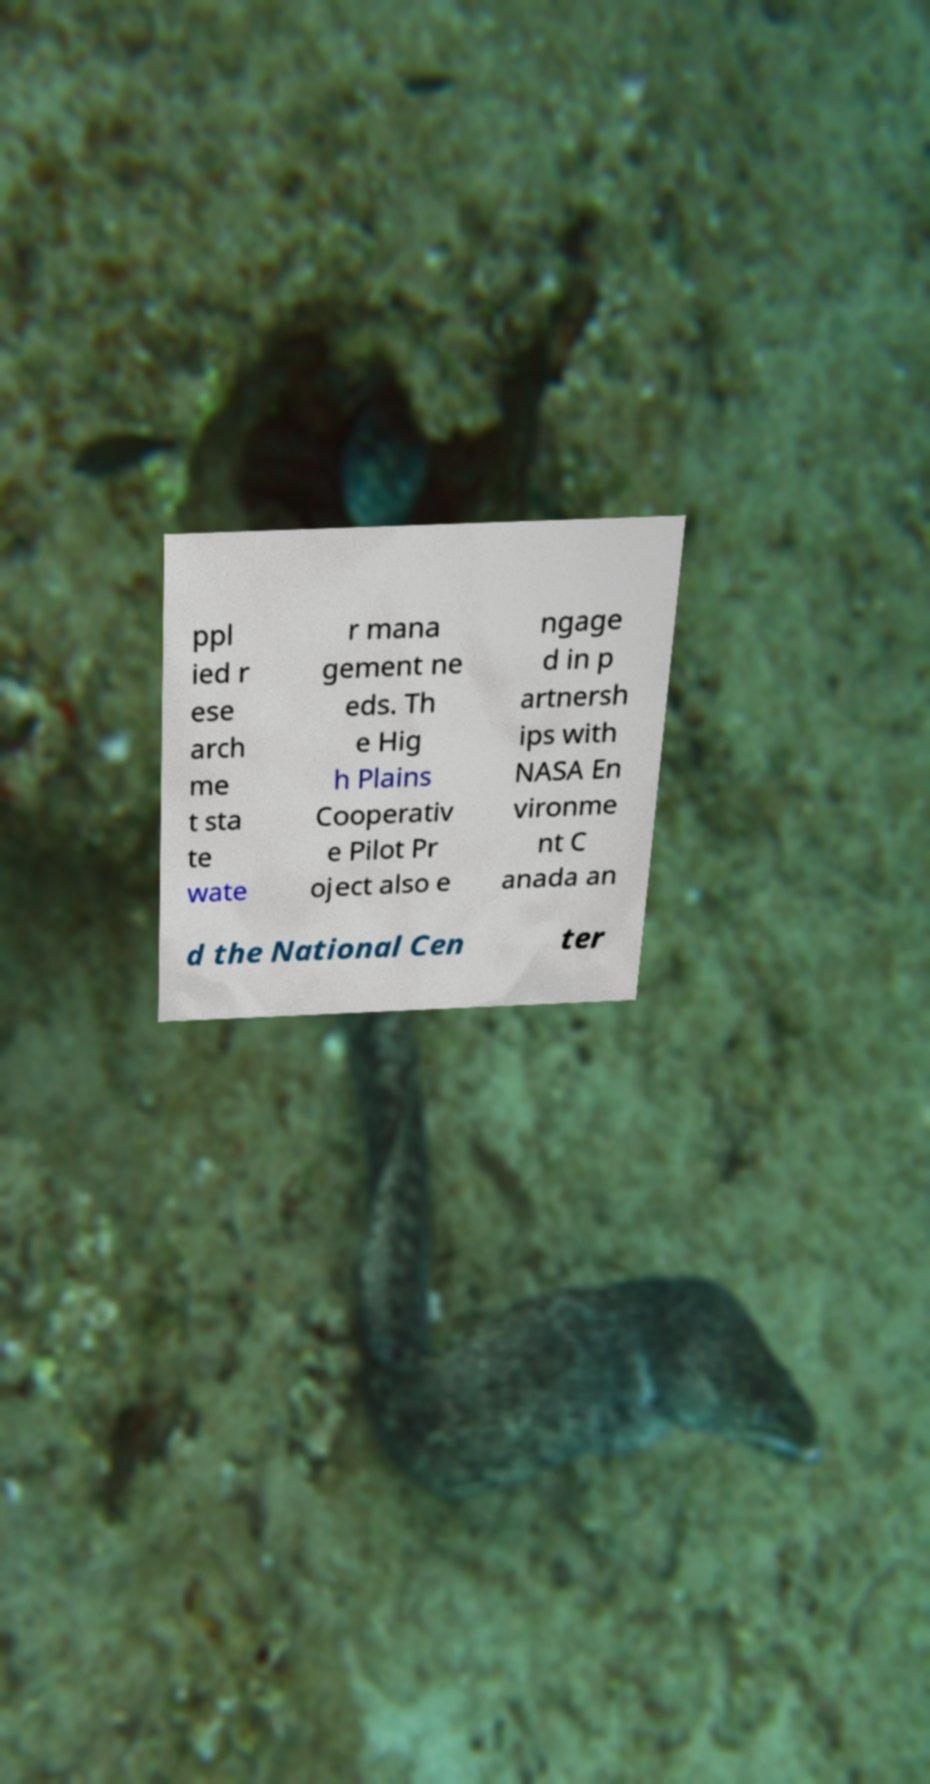Could you assist in decoding the text presented in this image and type it out clearly? ppl ied r ese arch me t sta te wate r mana gement ne eds. Th e Hig h Plains Cooperativ e Pilot Pr oject also e ngage d in p artnersh ips with NASA En vironme nt C anada an d the National Cen ter 